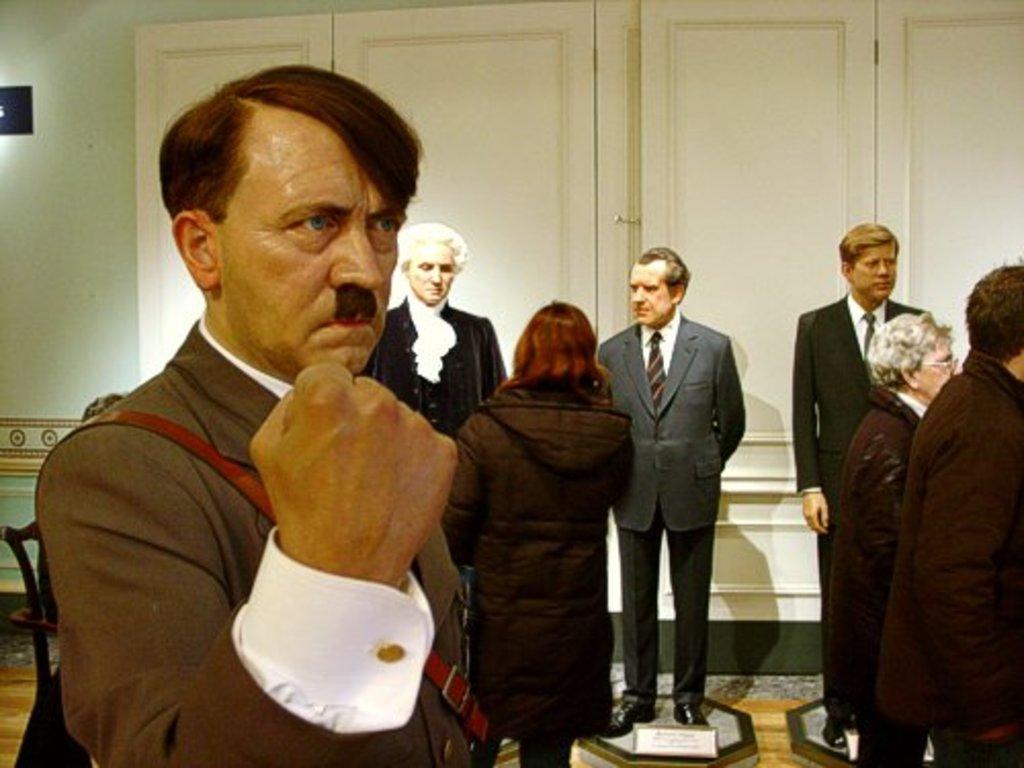Could you give a brief overview of what you see in this image? In this picture there are group of people standing. At the back there are cupboards on the wall. On the left side of the image there is a chair and there is a board on the wall. At the bottom there is a floor and there are boards and there is text on the boards. 